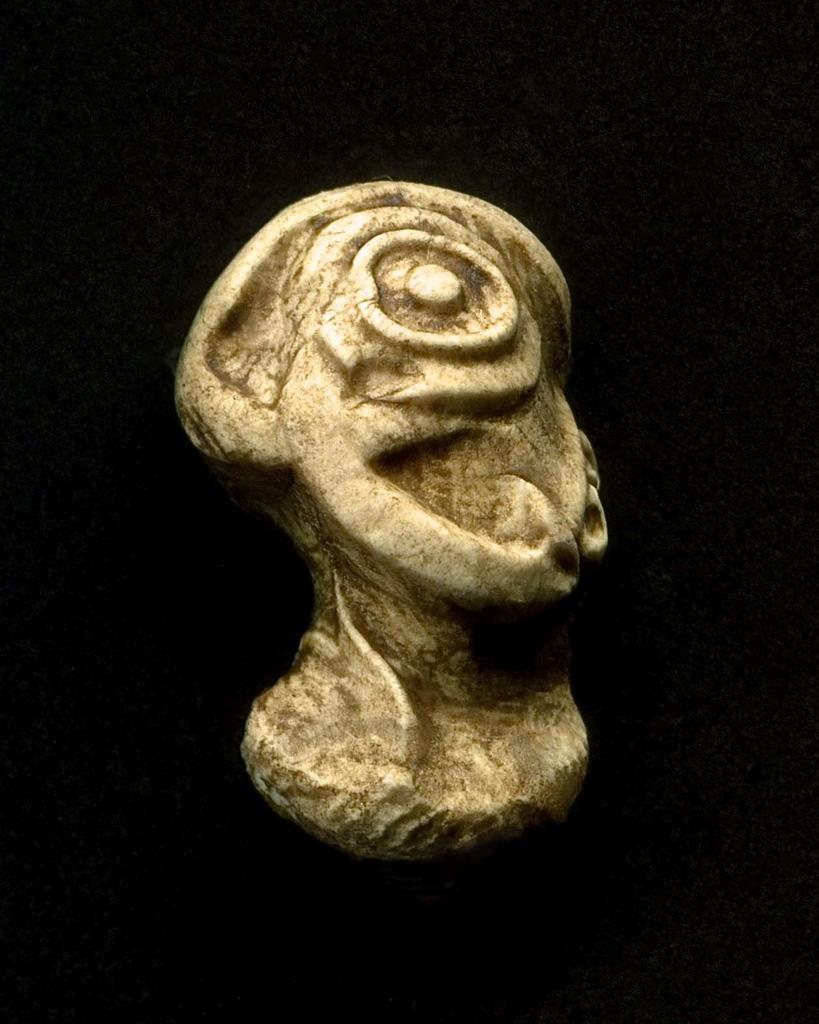What is the main subject of the image? The main subject of the image is a carved rock. Can you describe the appearance of the carved rock? The carved rock is cream and brown in color. What can be seen in the background of the image? The background of the image is black. How many cats are sitting on the brick in the image? There are no cats or bricks present in the image; it features a carved rock with a black background. 